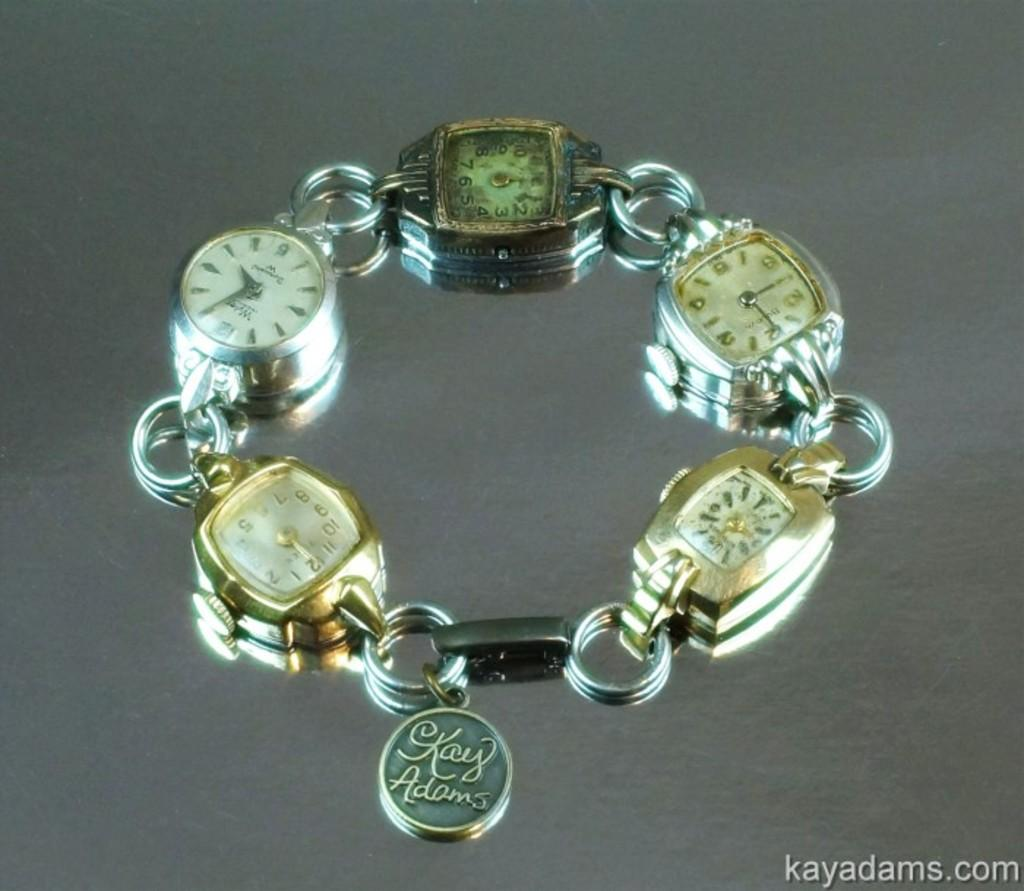Provide a one-sentence caption for the provided image. A bracelet of watch faces has a charm saying Kay Adams dangling near the clasp. 